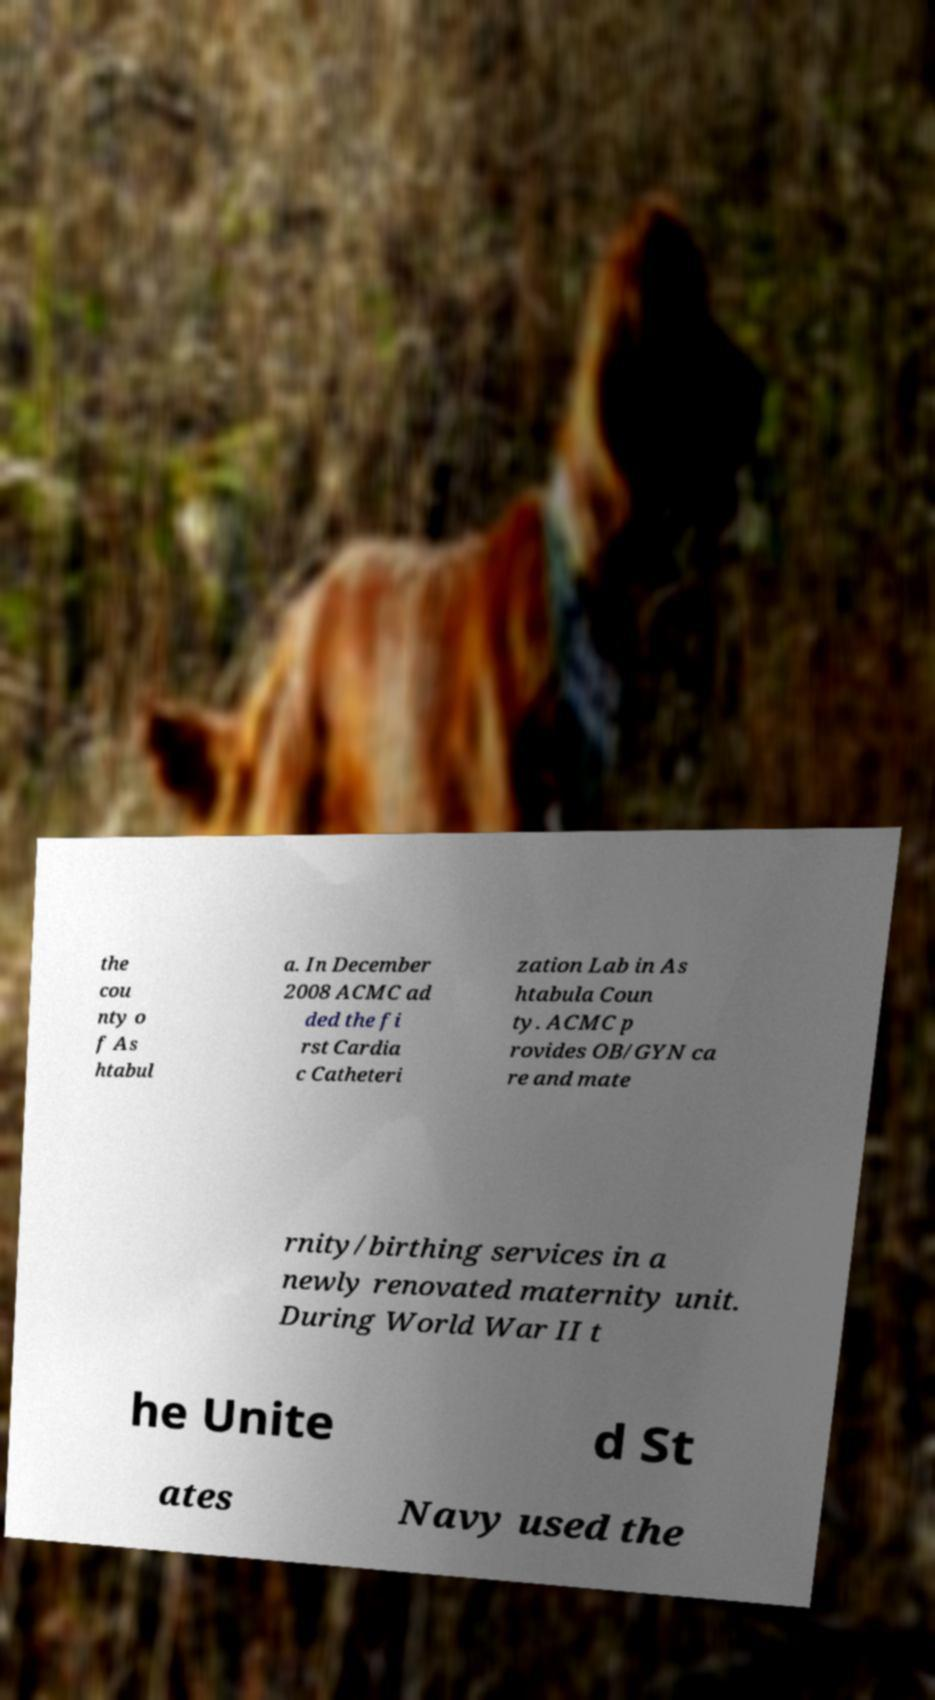I need the written content from this picture converted into text. Can you do that? the cou nty o f As htabul a. In December 2008 ACMC ad ded the fi rst Cardia c Catheteri zation Lab in As htabula Coun ty. ACMC p rovides OB/GYN ca re and mate rnity/birthing services in a newly renovated maternity unit. During World War II t he Unite d St ates Navy used the 